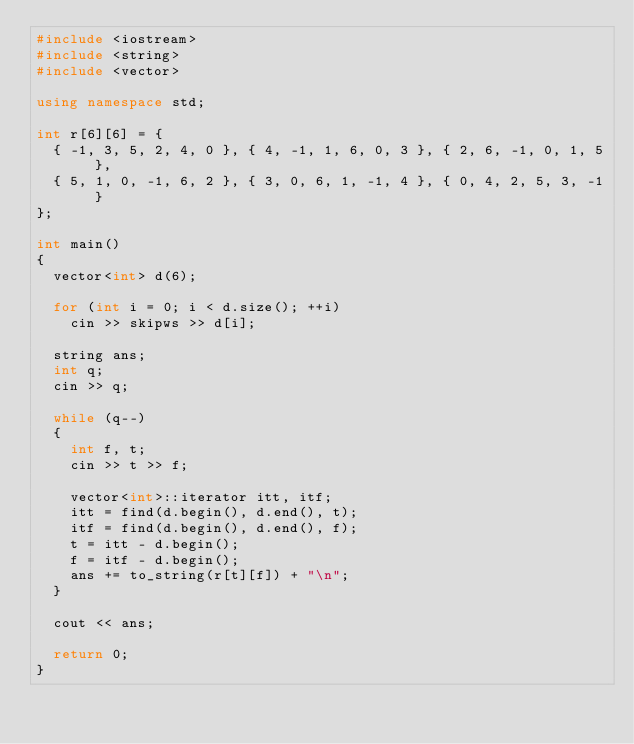Convert code to text. <code><loc_0><loc_0><loc_500><loc_500><_C++_>#include <iostream>
#include <string>
#include <vector>

using namespace std;

int r[6][6] = {
	{ -1, 3, 5, 2, 4, 0 }, { 4, -1, 1, 6, 0, 3 }, { 2, 6, -1, 0, 1, 5 },
	{ 5, 1, 0, -1, 6, 2 }, { 3, 0, 6, 1, -1, 4 }, { 0, 4, 2, 5, 3, -1 }
};

int main()
{
	vector<int> d(6);

	for (int i = 0; i < d.size(); ++i)
		cin >> skipws >> d[i];

	string ans;
	int q;
	cin >> q;

	while (q--)
	{
		int f, t;
		cin >> t >> f;

		vector<int>::iterator itt, itf;
		itt = find(d.begin(), d.end(), t);
		itf = find(d.begin(), d.end(), f);
		t = itt - d.begin();
		f = itf - d.begin();
		ans += to_string(r[t][f]) + "\n";
	}

	cout << ans;

	return 0;
}</code> 